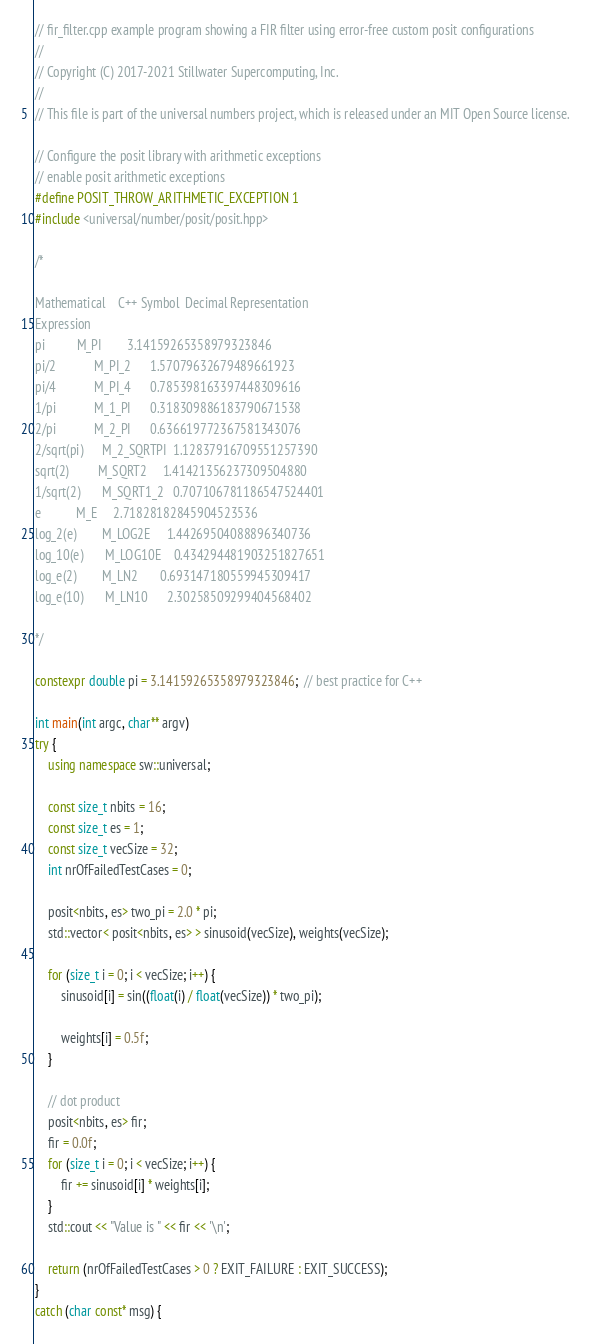Convert code to text. <code><loc_0><loc_0><loc_500><loc_500><_C++_>// fir_filter.cpp example program showing a FIR filter using error-free custom posit configurations
//
// Copyright (C) 2017-2021 Stillwater Supercomputing, Inc.
//
// This file is part of the universal numbers project, which is released under an MIT Open Source license.

// Configure the posit library with arithmetic exceptions
// enable posit arithmetic exceptions
#define POSIT_THROW_ARITHMETIC_EXCEPTION 1
#include <universal/number/posit/posit.hpp>

/*

Mathematical 	C++ Symbol	Decimal Representation
Expression
pi			M_PI		3.14159265358979323846
pi/2			M_PI_2		1.57079632679489661923
pi/4			M_PI_4		0.785398163397448309616
1/pi			M_1_PI		0.318309886183790671538
2/pi			M_2_PI		0.636619772367581343076
2/sqrt(pi)		M_2_SQRTPI	1.12837916709551257390
sqrt(2)			M_SQRT2		1.41421356237309504880
1/sqrt(2)		M_SQRT1_2	0.707106781186547524401
e			M_E		2.71828182845904523536
log_2(e)		M_LOG2E		1.44269504088896340736
log_10(e)		M_LOG10E	0.434294481903251827651
log_e(2)		M_LN2		0.693147180559945309417
log_e(10)		M_LN10		2.30258509299404568402

*/

constexpr double pi = 3.14159265358979323846;  // best practice for C++

int main(int argc, char** argv)
try {
	using namespace sw::universal;

	const size_t nbits = 16;
	const size_t es = 1;
	const size_t vecSize = 32;
	int nrOfFailedTestCases = 0;

	posit<nbits, es> two_pi = 2.0 * pi;
	std::vector< posit<nbits, es> > sinusoid(vecSize), weights(vecSize);

	for (size_t i = 0; i < vecSize; i++) {
		sinusoid[i] = sin((float(i) / float(vecSize)) * two_pi);

		weights[i] = 0.5f;
	}

	// dot product
	posit<nbits, es> fir;
	fir = 0.0f;
	for (size_t i = 0; i < vecSize; i++) {
		fir += sinusoid[i] * weights[i];
	}
	std::cout << "Value is " << fir << '\n';

	return (nrOfFailedTestCases > 0 ? EXIT_FAILURE : EXIT_SUCCESS);
}
catch (char const* msg) {</code> 